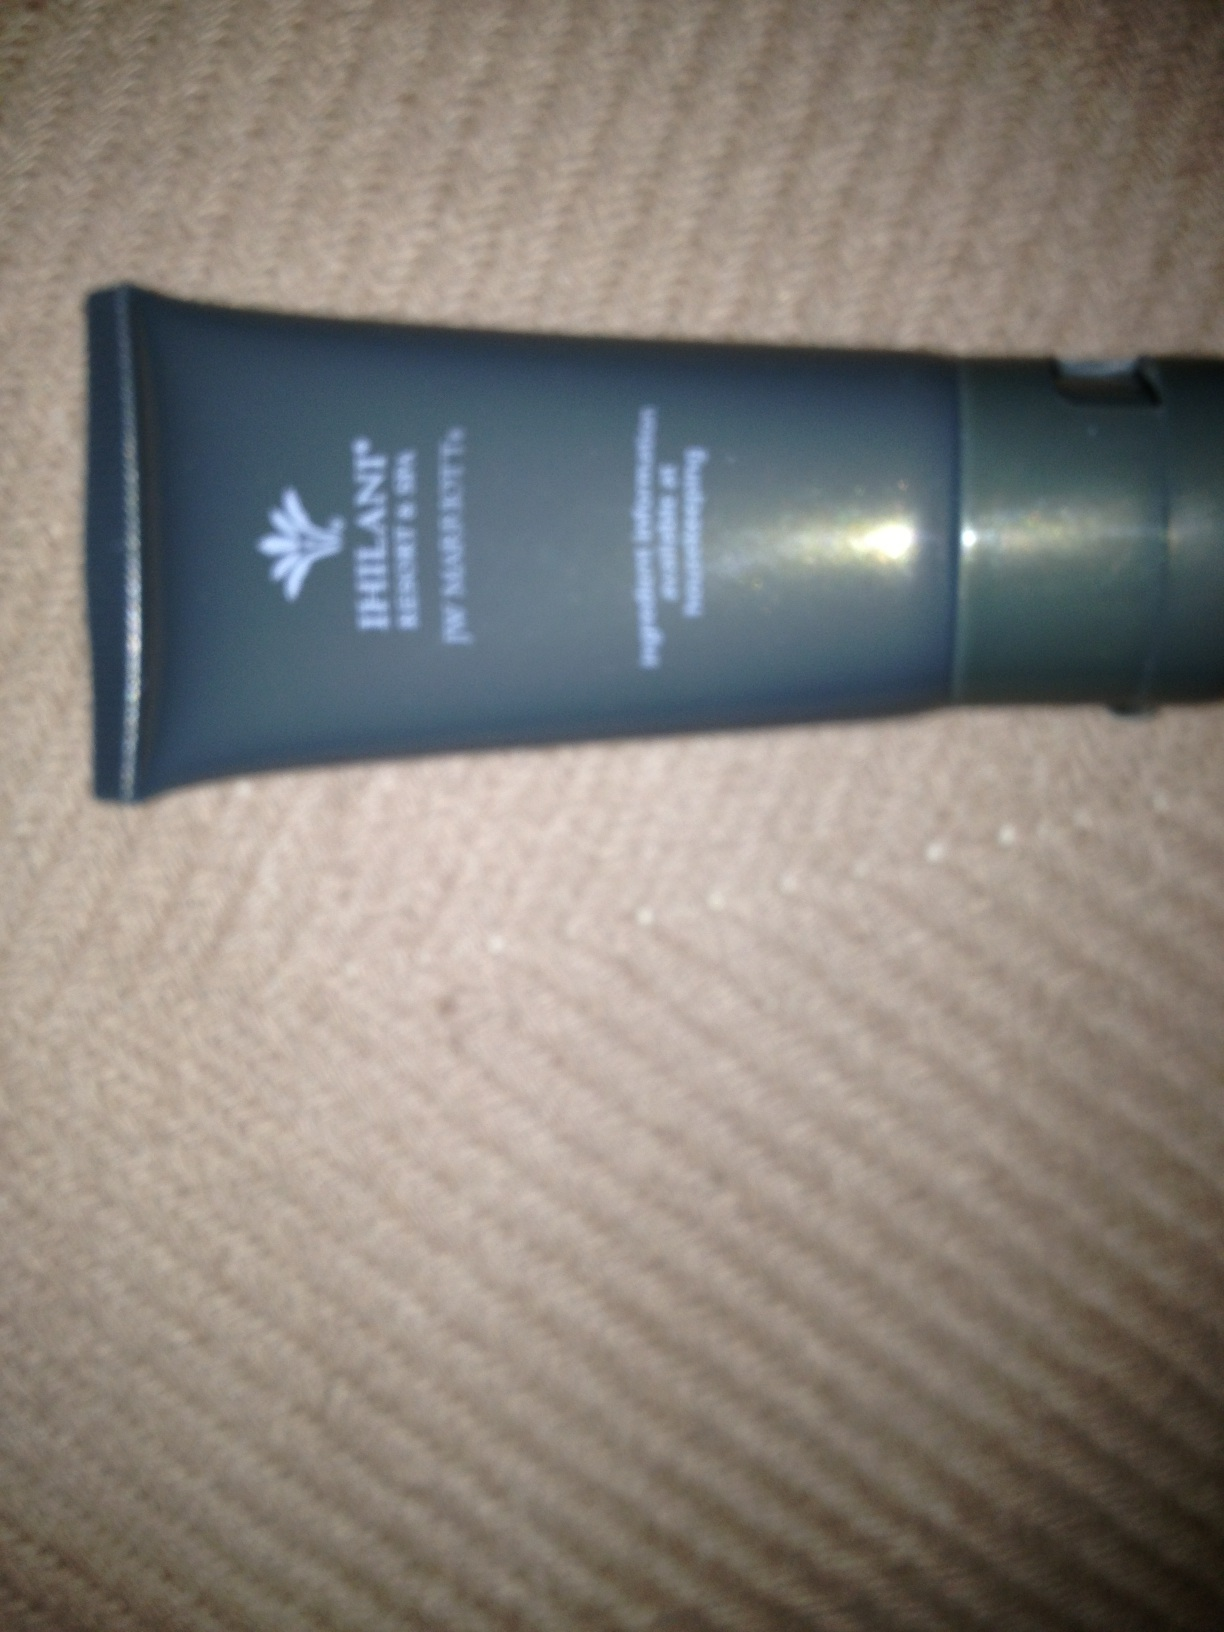Can you give me tips on how to take a clearer picture for product identification? Certainly! To take a clearer picture, make sure you have good lighting and a steady hand or use a tripod. Try to take the photo in natural light or well-lit conditions. Ensure the camera is focused on the product by tapping on the product on your screen if using a smartphone. Also, make sure to capture the entire product in frame from a slight distance to ensure legibility of text and clarity of details. 